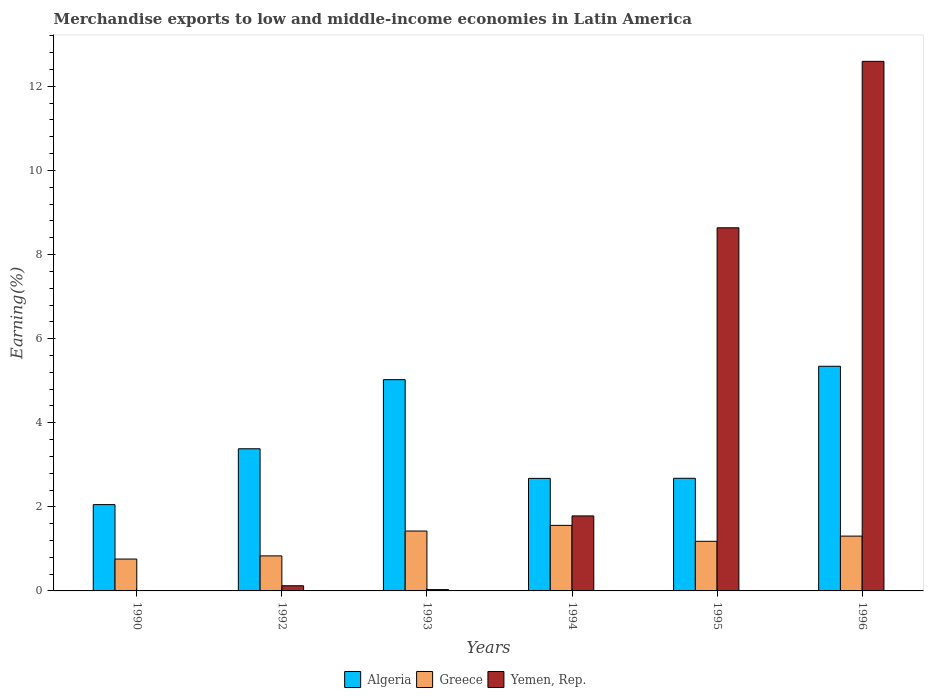How many bars are there on the 2nd tick from the right?
Provide a succinct answer. 3. What is the label of the 3rd group of bars from the left?
Your response must be concise. 1993. What is the percentage of amount earned from merchandise exports in Algeria in 1990?
Your answer should be compact. 2.05. Across all years, what is the maximum percentage of amount earned from merchandise exports in Greece?
Provide a short and direct response. 1.56. Across all years, what is the minimum percentage of amount earned from merchandise exports in Greece?
Give a very brief answer. 0.76. What is the total percentage of amount earned from merchandise exports in Greece in the graph?
Ensure brevity in your answer.  7.06. What is the difference between the percentage of amount earned from merchandise exports in Algeria in 1990 and that in 1994?
Keep it short and to the point. -0.62. What is the difference between the percentage of amount earned from merchandise exports in Yemen, Rep. in 1996 and the percentage of amount earned from merchandise exports in Algeria in 1994?
Offer a very short reply. 9.92. What is the average percentage of amount earned from merchandise exports in Algeria per year?
Your response must be concise. 3.53. In the year 1994, what is the difference between the percentage of amount earned from merchandise exports in Yemen, Rep. and percentage of amount earned from merchandise exports in Greece?
Your answer should be very brief. 0.23. What is the ratio of the percentage of amount earned from merchandise exports in Greece in 1992 to that in 1994?
Your answer should be compact. 0.53. Is the difference between the percentage of amount earned from merchandise exports in Yemen, Rep. in 1990 and 1992 greater than the difference between the percentage of amount earned from merchandise exports in Greece in 1990 and 1992?
Offer a very short reply. No. What is the difference between the highest and the second highest percentage of amount earned from merchandise exports in Algeria?
Give a very brief answer. 0.32. What is the difference between the highest and the lowest percentage of amount earned from merchandise exports in Yemen, Rep.?
Keep it short and to the point. 12.59. In how many years, is the percentage of amount earned from merchandise exports in Algeria greater than the average percentage of amount earned from merchandise exports in Algeria taken over all years?
Keep it short and to the point. 2. Is the sum of the percentage of amount earned from merchandise exports in Algeria in 1992 and 1995 greater than the maximum percentage of amount earned from merchandise exports in Greece across all years?
Keep it short and to the point. Yes. What does the 3rd bar from the left in 1994 represents?
Your answer should be compact. Yemen, Rep. What does the 1st bar from the right in 1994 represents?
Your answer should be compact. Yemen, Rep. Is it the case that in every year, the sum of the percentage of amount earned from merchandise exports in Yemen, Rep. and percentage of amount earned from merchandise exports in Greece is greater than the percentage of amount earned from merchandise exports in Algeria?
Your response must be concise. No. How many bars are there?
Make the answer very short. 18. How many years are there in the graph?
Keep it short and to the point. 6. Are the values on the major ticks of Y-axis written in scientific E-notation?
Make the answer very short. No. Does the graph contain grids?
Provide a succinct answer. No. How many legend labels are there?
Your answer should be very brief. 3. How are the legend labels stacked?
Provide a short and direct response. Horizontal. What is the title of the graph?
Give a very brief answer. Merchandise exports to low and middle-income economies in Latin America. Does "Gambia, The" appear as one of the legend labels in the graph?
Your answer should be very brief. No. What is the label or title of the Y-axis?
Ensure brevity in your answer.  Earning(%). What is the Earning(%) of Algeria in 1990?
Offer a terse response. 2.05. What is the Earning(%) in Greece in 1990?
Give a very brief answer. 0.76. What is the Earning(%) of Yemen, Rep. in 1990?
Keep it short and to the point. 0. What is the Earning(%) in Algeria in 1992?
Your answer should be compact. 3.38. What is the Earning(%) of Greece in 1992?
Your response must be concise. 0.83. What is the Earning(%) of Yemen, Rep. in 1992?
Give a very brief answer. 0.12. What is the Earning(%) of Algeria in 1993?
Provide a short and direct response. 5.02. What is the Earning(%) in Greece in 1993?
Ensure brevity in your answer.  1.42. What is the Earning(%) of Yemen, Rep. in 1993?
Make the answer very short. 0.03. What is the Earning(%) of Algeria in 1994?
Your answer should be compact. 2.68. What is the Earning(%) of Greece in 1994?
Your response must be concise. 1.56. What is the Earning(%) of Yemen, Rep. in 1994?
Ensure brevity in your answer.  1.78. What is the Earning(%) in Algeria in 1995?
Make the answer very short. 2.68. What is the Earning(%) of Greece in 1995?
Ensure brevity in your answer.  1.18. What is the Earning(%) in Yemen, Rep. in 1995?
Offer a very short reply. 8.64. What is the Earning(%) of Algeria in 1996?
Offer a very short reply. 5.34. What is the Earning(%) of Greece in 1996?
Provide a short and direct response. 1.3. What is the Earning(%) in Yemen, Rep. in 1996?
Offer a terse response. 12.59. Across all years, what is the maximum Earning(%) of Algeria?
Make the answer very short. 5.34. Across all years, what is the maximum Earning(%) in Greece?
Provide a short and direct response. 1.56. Across all years, what is the maximum Earning(%) of Yemen, Rep.?
Your answer should be compact. 12.59. Across all years, what is the minimum Earning(%) in Algeria?
Offer a very short reply. 2.05. Across all years, what is the minimum Earning(%) of Greece?
Make the answer very short. 0.76. Across all years, what is the minimum Earning(%) in Yemen, Rep.?
Make the answer very short. 0. What is the total Earning(%) in Algeria in the graph?
Provide a short and direct response. 21.16. What is the total Earning(%) in Greece in the graph?
Your response must be concise. 7.06. What is the total Earning(%) of Yemen, Rep. in the graph?
Your answer should be compact. 23.17. What is the difference between the Earning(%) in Algeria in 1990 and that in 1992?
Your answer should be compact. -1.33. What is the difference between the Earning(%) in Greece in 1990 and that in 1992?
Your answer should be very brief. -0.08. What is the difference between the Earning(%) of Yemen, Rep. in 1990 and that in 1992?
Make the answer very short. -0.12. What is the difference between the Earning(%) in Algeria in 1990 and that in 1993?
Give a very brief answer. -2.97. What is the difference between the Earning(%) in Greece in 1990 and that in 1993?
Your answer should be compact. -0.67. What is the difference between the Earning(%) in Yemen, Rep. in 1990 and that in 1993?
Your answer should be compact. -0.03. What is the difference between the Earning(%) in Algeria in 1990 and that in 1994?
Your answer should be compact. -0.62. What is the difference between the Earning(%) of Greece in 1990 and that in 1994?
Offer a very short reply. -0.8. What is the difference between the Earning(%) in Yemen, Rep. in 1990 and that in 1994?
Your answer should be compact. -1.78. What is the difference between the Earning(%) in Algeria in 1990 and that in 1995?
Offer a very short reply. -0.63. What is the difference between the Earning(%) of Greece in 1990 and that in 1995?
Your response must be concise. -0.42. What is the difference between the Earning(%) of Yemen, Rep. in 1990 and that in 1995?
Ensure brevity in your answer.  -8.63. What is the difference between the Earning(%) of Algeria in 1990 and that in 1996?
Give a very brief answer. -3.29. What is the difference between the Earning(%) of Greece in 1990 and that in 1996?
Make the answer very short. -0.55. What is the difference between the Earning(%) in Yemen, Rep. in 1990 and that in 1996?
Your answer should be compact. -12.59. What is the difference between the Earning(%) in Algeria in 1992 and that in 1993?
Provide a short and direct response. -1.64. What is the difference between the Earning(%) in Greece in 1992 and that in 1993?
Keep it short and to the point. -0.59. What is the difference between the Earning(%) in Yemen, Rep. in 1992 and that in 1993?
Your answer should be very brief. 0.09. What is the difference between the Earning(%) in Algeria in 1992 and that in 1994?
Your answer should be very brief. 0.7. What is the difference between the Earning(%) of Greece in 1992 and that in 1994?
Your answer should be compact. -0.73. What is the difference between the Earning(%) of Yemen, Rep. in 1992 and that in 1994?
Provide a succinct answer. -1.66. What is the difference between the Earning(%) in Algeria in 1992 and that in 1995?
Your response must be concise. 0.7. What is the difference between the Earning(%) in Greece in 1992 and that in 1995?
Make the answer very short. -0.35. What is the difference between the Earning(%) in Yemen, Rep. in 1992 and that in 1995?
Keep it short and to the point. -8.51. What is the difference between the Earning(%) in Algeria in 1992 and that in 1996?
Provide a succinct answer. -1.96. What is the difference between the Earning(%) of Greece in 1992 and that in 1996?
Make the answer very short. -0.47. What is the difference between the Earning(%) in Yemen, Rep. in 1992 and that in 1996?
Offer a terse response. -12.47. What is the difference between the Earning(%) in Algeria in 1993 and that in 1994?
Provide a succinct answer. 2.35. What is the difference between the Earning(%) in Greece in 1993 and that in 1994?
Offer a terse response. -0.13. What is the difference between the Earning(%) in Yemen, Rep. in 1993 and that in 1994?
Keep it short and to the point. -1.75. What is the difference between the Earning(%) of Algeria in 1993 and that in 1995?
Ensure brevity in your answer.  2.35. What is the difference between the Earning(%) of Greece in 1993 and that in 1995?
Make the answer very short. 0.24. What is the difference between the Earning(%) of Yemen, Rep. in 1993 and that in 1995?
Your answer should be compact. -8.61. What is the difference between the Earning(%) in Algeria in 1993 and that in 1996?
Offer a very short reply. -0.32. What is the difference between the Earning(%) in Greece in 1993 and that in 1996?
Offer a terse response. 0.12. What is the difference between the Earning(%) of Yemen, Rep. in 1993 and that in 1996?
Provide a short and direct response. -12.56. What is the difference between the Earning(%) of Algeria in 1994 and that in 1995?
Make the answer very short. -0. What is the difference between the Earning(%) in Greece in 1994 and that in 1995?
Provide a succinct answer. 0.38. What is the difference between the Earning(%) in Yemen, Rep. in 1994 and that in 1995?
Provide a short and direct response. -6.85. What is the difference between the Earning(%) of Algeria in 1994 and that in 1996?
Your answer should be compact. -2.67. What is the difference between the Earning(%) of Greece in 1994 and that in 1996?
Provide a succinct answer. 0.26. What is the difference between the Earning(%) of Yemen, Rep. in 1994 and that in 1996?
Offer a terse response. -10.81. What is the difference between the Earning(%) of Algeria in 1995 and that in 1996?
Provide a succinct answer. -2.66. What is the difference between the Earning(%) in Greece in 1995 and that in 1996?
Give a very brief answer. -0.12. What is the difference between the Earning(%) of Yemen, Rep. in 1995 and that in 1996?
Ensure brevity in your answer.  -3.96. What is the difference between the Earning(%) of Algeria in 1990 and the Earning(%) of Greece in 1992?
Make the answer very short. 1.22. What is the difference between the Earning(%) of Algeria in 1990 and the Earning(%) of Yemen, Rep. in 1992?
Provide a short and direct response. 1.93. What is the difference between the Earning(%) of Greece in 1990 and the Earning(%) of Yemen, Rep. in 1992?
Your answer should be very brief. 0.64. What is the difference between the Earning(%) of Algeria in 1990 and the Earning(%) of Greece in 1993?
Offer a very short reply. 0.63. What is the difference between the Earning(%) of Algeria in 1990 and the Earning(%) of Yemen, Rep. in 1993?
Ensure brevity in your answer.  2.02. What is the difference between the Earning(%) in Greece in 1990 and the Earning(%) in Yemen, Rep. in 1993?
Make the answer very short. 0.73. What is the difference between the Earning(%) in Algeria in 1990 and the Earning(%) in Greece in 1994?
Give a very brief answer. 0.49. What is the difference between the Earning(%) of Algeria in 1990 and the Earning(%) of Yemen, Rep. in 1994?
Offer a terse response. 0.27. What is the difference between the Earning(%) of Greece in 1990 and the Earning(%) of Yemen, Rep. in 1994?
Ensure brevity in your answer.  -1.03. What is the difference between the Earning(%) in Algeria in 1990 and the Earning(%) in Greece in 1995?
Ensure brevity in your answer.  0.87. What is the difference between the Earning(%) of Algeria in 1990 and the Earning(%) of Yemen, Rep. in 1995?
Your answer should be compact. -6.58. What is the difference between the Earning(%) in Greece in 1990 and the Earning(%) in Yemen, Rep. in 1995?
Provide a succinct answer. -7.88. What is the difference between the Earning(%) of Algeria in 1990 and the Earning(%) of Greece in 1996?
Make the answer very short. 0.75. What is the difference between the Earning(%) of Algeria in 1990 and the Earning(%) of Yemen, Rep. in 1996?
Give a very brief answer. -10.54. What is the difference between the Earning(%) in Greece in 1990 and the Earning(%) in Yemen, Rep. in 1996?
Provide a succinct answer. -11.84. What is the difference between the Earning(%) in Algeria in 1992 and the Earning(%) in Greece in 1993?
Your answer should be very brief. 1.96. What is the difference between the Earning(%) in Algeria in 1992 and the Earning(%) in Yemen, Rep. in 1993?
Your answer should be very brief. 3.35. What is the difference between the Earning(%) of Greece in 1992 and the Earning(%) of Yemen, Rep. in 1993?
Ensure brevity in your answer.  0.8. What is the difference between the Earning(%) in Algeria in 1992 and the Earning(%) in Greece in 1994?
Give a very brief answer. 1.82. What is the difference between the Earning(%) in Algeria in 1992 and the Earning(%) in Yemen, Rep. in 1994?
Keep it short and to the point. 1.6. What is the difference between the Earning(%) in Greece in 1992 and the Earning(%) in Yemen, Rep. in 1994?
Ensure brevity in your answer.  -0.95. What is the difference between the Earning(%) in Algeria in 1992 and the Earning(%) in Greece in 1995?
Your response must be concise. 2.2. What is the difference between the Earning(%) of Algeria in 1992 and the Earning(%) of Yemen, Rep. in 1995?
Ensure brevity in your answer.  -5.26. What is the difference between the Earning(%) of Greece in 1992 and the Earning(%) of Yemen, Rep. in 1995?
Your answer should be very brief. -7.8. What is the difference between the Earning(%) in Algeria in 1992 and the Earning(%) in Greece in 1996?
Offer a terse response. 2.08. What is the difference between the Earning(%) of Algeria in 1992 and the Earning(%) of Yemen, Rep. in 1996?
Give a very brief answer. -9.21. What is the difference between the Earning(%) of Greece in 1992 and the Earning(%) of Yemen, Rep. in 1996?
Provide a short and direct response. -11.76. What is the difference between the Earning(%) in Algeria in 1993 and the Earning(%) in Greece in 1994?
Offer a terse response. 3.47. What is the difference between the Earning(%) of Algeria in 1993 and the Earning(%) of Yemen, Rep. in 1994?
Make the answer very short. 3.24. What is the difference between the Earning(%) in Greece in 1993 and the Earning(%) in Yemen, Rep. in 1994?
Offer a very short reply. -0.36. What is the difference between the Earning(%) of Algeria in 1993 and the Earning(%) of Greece in 1995?
Your response must be concise. 3.85. What is the difference between the Earning(%) in Algeria in 1993 and the Earning(%) in Yemen, Rep. in 1995?
Your response must be concise. -3.61. What is the difference between the Earning(%) in Greece in 1993 and the Earning(%) in Yemen, Rep. in 1995?
Your answer should be very brief. -7.21. What is the difference between the Earning(%) of Algeria in 1993 and the Earning(%) of Greece in 1996?
Make the answer very short. 3.72. What is the difference between the Earning(%) of Algeria in 1993 and the Earning(%) of Yemen, Rep. in 1996?
Your response must be concise. -7.57. What is the difference between the Earning(%) in Greece in 1993 and the Earning(%) in Yemen, Rep. in 1996?
Provide a short and direct response. -11.17. What is the difference between the Earning(%) in Algeria in 1994 and the Earning(%) in Greece in 1995?
Your response must be concise. 1.5. What is the difference between the Earning(%) of Algeria in 1994 and the Earning(%) of Yemen, Rep. in 1995?
Offer a very short reply. -5.96. What is the difference between the Earning(%) of Greece in 1994 and the Earning(%) of Yemen, Rep. in 1995?
Your answer should be compact. -7.08. What is the difference between the Earning(%) in Algeria in 1994 and the Earning(%) in Greece in 1996?
Offer a very short reply. 1.37. What is the difference between the Earning(%) in Algeria in 1994 and the Earning(%) in Yemen, Rep. in 1996?
Offer a very short reply. -9.92. What is the difference between the Earning(%) in Greece in 1994 and the Earning(%) in Yemen, Rep. in 1996?
Give a very brief answer. -11.04. What is the difference between the Earning(%) in Algeria in 1995 and the Earning(%) in Greece in 1996?
Offer a very short reply. 1.38. What is the difference between the Earning(%) of Algeria in 1995 and the Earning(%) of Yemen, Rep. in 1996?
Make the answer very short. -9.92. What is the difference between the Earning(%) of Greece in 1995 and the Earning(%) of Yemen, Rep. in 1996?
Offer a terse response. -11.41. What is the average Earning(%) in Algeria per year?
Your response must be concise. 3.53. What is the average Earning(%) in Greece per year?
Keep it short and to the point. 1.18. What is the average Earning(%) in Yemen, Rep. per year?
Your response must be concise. 3.86. In the year 1990, what is the difference between the Earning(%) in Algeria and Earning(%) in Greece?
Keep it short and to the point. 1.29. In the year 1990, what is the difference between the Earning(%) of Algeria and Earning(%) of Yemen, Rep.?
Make the answer very short. 2.05. In the year 1990, what is the difference between the Earning(%) of Greece and Earning(%) of Yemen, Rep.?
Make the answer very short. 0.76. In the year 1992, what is the difference between the Earning(%) in Algeria and Earning(%) in Greece?
Ensure brevity in your answer.  2.55. In the year 1992, what is the difference between the Earning(%) in Algeria and Earning(%) in Yemen, Rep.?
Give a very brief answer. 3.26. In the year 1992, what is the difference between the Earning(%) in Greece and Earning(%) in Yemen, Rep.?
Offer a terse response. 0.71. In the year 1993, what is the difference between the Earning(%) in Algeria and Earning(%) in Greece?
Your answer should be compact. 3.6. In the year 1993, what is the difference between the Earning(%) in Algeria and Earning(%) in Yemen, Rep.?
Your response must be concise. 4.99. In the year 1993, what is the difference between the Earning(%) of Greece and Earning(%) of Yemen, Rep.?
Your response must be concise. 1.39. In the year 1994, what is the difference between the Earning(%) of Algeria and Earning(%) of Greece?
Provide a succinct answer. 1.12. In the year 1994, what is the difference between the Earning(%) of Algeria and Earning(%) of Yemen, Rep.?
Offer a very short reply. 0.89. In the year 1994, what is the difference between the Earning(%) in Greece and Earning(%) in Yemen, Rep.?
Offer a very short reply. -0.23. In the year 1995, what is the difference between the Earning(%) in Algeria and Earning(%) in Greece?
Your answer should be compact. 1.5. In the year 1995, what is the difference between the Earning(%) of Algeria and Earning(%) of Yemen, Rep.?
Your answer should be very brief. -5.96. In the year 1995, what is the difference between the Earning(%) of Greece and Earning(%) of Yemen, Rep.?
Make the answer very short. -7.46. In the year 1996, what is the difference between the Earning(%) of Algeria and Earning(%) of Greece?
Offer a very short reply. 4.04. In the year 1996, what is the difference between the Earning(%) in Algeria and Earning(%) in Yemen, Rep.?
Provide a short and direct response. -7.25. In the year 1996, what is the difference between the Earning(%) of Greece and Earning(%) of Yemen, Rep.?
Ensure brevity in your answer.  -11.29. What is the ratio of the Earning(%) of Algeria in 1990 to that in 1992?
Offer a terse response. 0.61. What is the ratio of the Earning(%) in Greece in 1990 to that in 1992?
Provide a succinct answer. 0.91. What is the ratio of the Earning(%) in Yemen, Rep. in 1990 to that in 1992?
Provide a succinct answer. 0.02. What is the ratio of the Earning(%) of Algeria in 1990 to that in 1993?
Offer a terse response. 0.41. What is the ratio of the Earning(%) of Greece in 1990 to that in 1993?
Offer a very short reply. 0.53. What is the ratio of the Earning(%) in Yemen, Rep. in 1990 to that in 1993?
Provide a succinct answer. 0.07. What is the ratio of the Earning(%) of Algeria in 1990 to that in 1994?
Your answer should be compact. 0.77. What is the ratio of the Earning(%) in Greece in 1990 to that in 1994?
Your answer should be compact. 0.49. What is the ratio of the Earning(%) of Yemen, Rep. in 1990 to that in 1994?
Your answer should be compact. 0. What is the ratio of the Earning(%) in Algeria in 1990 to that in 1995?
Your answer should be very brief. 0.77. What is the ratio of the Earning(%) in Greece in 1990 to that in 1995?
Provide a succinct answer. 0.64. What is the ratio of the Earning(%) of Yemen, Rep. in 1990 to that in 1995?
Ensure brevity in your answer.  0. What is the ratio of the Earning(%) of Algeria in 1990 to that in 1996?
Offer a terse response. 0.38. What is the ratio of the Earning(%) in Greece in 1990 to that in 1996?
Make the answer very short. 0.58. What is the ratio of the Earning(%) in Algeria in 1992 to that in 1993?
Provide a short and direct response. 0.67. What is the ratio of the Earning(%) of Greece in 1992 to that in 1993?
Your answer should be very brief. 0.58. What is the ratio of the Earning(%) in Yemen, Rep. in 1992 to that in 1993?
Your answer should be compact. 3.97. What is the ratio of the Earning(%) in Algeria in 1992 to that in 1994?
Provide a succinct answer. 1.26. What is the ratio of the Earning(%) in Greece in 1992 to that in 1994?
Ensure brevity in your answer.  0.53. What is the ratio of the Earning(%) of Yemen, Rep. in 1992 to that in 1994?
Offer a terse response. 0.07. What is the ratio of the Earning(%) of Algeria in 1992 to that in 1995?
Keep it short and to the point. 1.26. What is the ratio of the Earning(%) of Greece in 1992 to that in 1995?
Provide a short and direct response. 0.71. What is the ratio of the Earning(%) in Yemen, Rep. in 1992 to that in 1995?
Offer a terse response. 0.01. What is the ratio of the Earning(%) of Algeria in 1992 to that in 1996?
Make the answer very short. 0.63. What is the ratio of the Earning(%) in Greece in 1992 to that in 1996?
Give a very brief answer. 0.64. What is the ratio of the Earning(%) of Yemen, Rep. in 1992 to that in 1996?
Make the answer very short. 0.01. What is the ratio of the Earning(%) in Algeria in 1993 to that in 1994?
Keep it short and to the point. 1.88. What is the ratio of the Earning(%) in Greece in 1993 to that in 1994?
Your answer should be compact. 0.91. What is the ratio of the Earning(%) in Yemen, Rep. in 1993 to that in 1994?
Your answer should be compact. 0.02. What is the ratio of the Earning(%) of Algeria in 1993 to that in 1995?
Provide a succinct answer. 1.88. What is the ratio of the Earning(%) of Greece in 1993 to that in 1995?
Ensure brevity in your answer.  1.21. What is the ratio of the Earning(%) in Yemen, Rep. in 1993 to that in 1995?
Make the answer very short. 0. What is the ratio of the Earning(%) of Algeria in 1993 to that in 1996?
Provide a short and direct response. 0.94. What is the ratio of the Earning(%) of Greece in 1993 to that in 1996?
Provide a succinct answer. 1.09. What is the ratio of the Earning(%) in Yemen, Rep. in 1993 to that in 1996?
Keep it short and to the point. 0. What is the ratio of the Earning(%) of Greece in 1994 to that in 1995?
Provide a short and direct response. 1.32. What is the ratio of the Earning(%) of Yemen, Rep. in 1994 to that in 1995?
Your answer should be compact. 0.21. What is the ratio of the Earning(%) of Algeria in 1994 to that in 1996?
Your answer should be very brief. 0.5. What is the ratio of the Earning(%) of Greece in 1994 to that in 1996?
Provide a succinct answer. 1.2. What is the ratio of the Earning(%) of Yemen, Rep. in 1994 to that in 1996?
Provide a succinct answer. 0.14. What is the ratio of the Earning(%) in Algeria in 1995 to that in 1996?
Your answer should be compact. 0.5. What is the ratio of the Earning(%) of Greece in 1995 to that in 1996?
Ensure brevity in your answer.  0.9. What is the ratio of the Earning(%) of Yemen, Rep. in 1995 to that in 1996?
Give a very brief answer. 0.69. What is the difference between the highest and the second highest Earning(%) in Algeria?
Offer a very short reply. 0.32. What is the difference between the highest and the second highest Earning(%) of Greece?
Your answer should be compact. 0.13. What is the difference between the highest and the second highest Earning(%) in Yemen, Rep.?
Make the answer very short. 3.96. What is the difference between the highest and the lowest Earning(%) of Algeria?
Your response must be concise. 3.29. What is the difference between the highest and the lowest Earning(%) of Greece?
Keep it short and to the point. 0.8. What is the difference between the highest and the lowest Earning(%) of Yemen, Rep.?
Give a very brief answer. 12.59. 